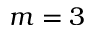Convert formula to latex. <formula><loc_0><loc_0><loc_500><loc_500>m = 3</formula> 